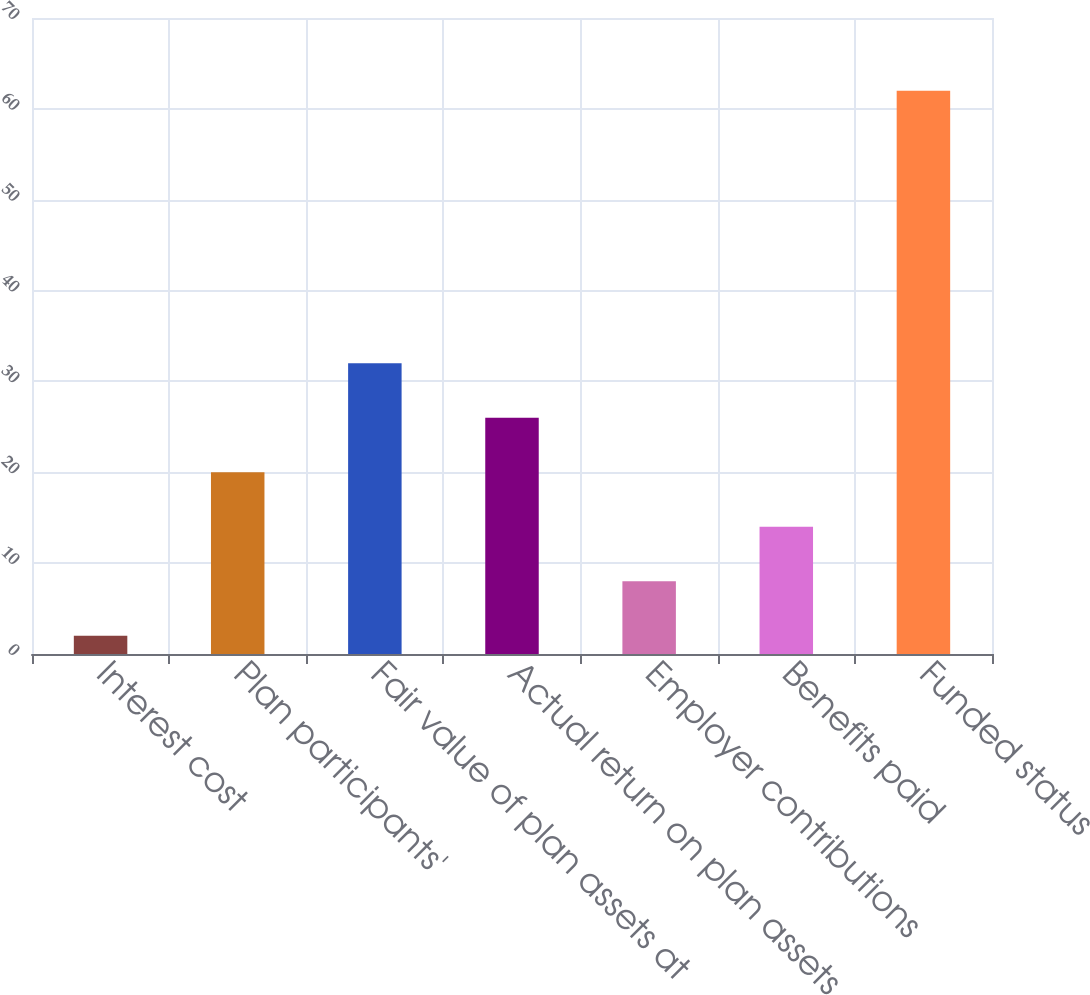<chart> <loc_0><loc_0><loc_500><loc_500><bar_chart><fcel>Interest cost<fcel>Plan participants'<fcel>Fair value of plan assets at<fcel>Actual return on plan assets<fcel>Employer contributions<fcel>Benefits paid<fcel>Funded status<nl><fcel>2<fcel>20<fcel>32<fcel>26<fcel>8<fcel>14<fcel>62<nl></chart> 